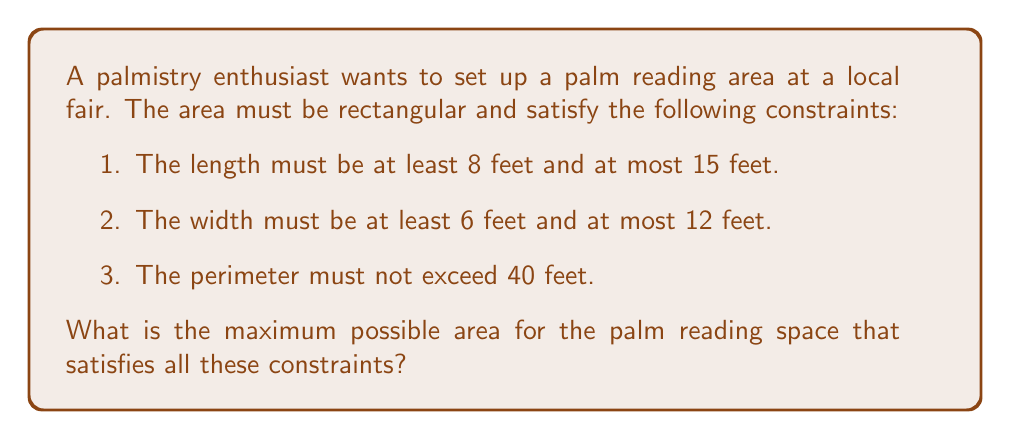What is the answer to this math problem? Let's approach this step-by-step:

1) Let $x$ be the length and $y$ be the width of the rectangular area.

2) From the given constraints, we can write the system of inequalities:
   $$8 \leq x \leq 15$$
   $$6 \leq y \leq 12$$
   $$2x + 2y \leq 40$$ (perimeter constraint)

3) The area of the rectangle is given by $A = xy$. We want to maximize this.

4) In a rectangular maximization problem with linear constraints, the maximum always occurs at a corner point of the feasible region.

5) The corner points are the intersections of the constraint lines. Let's find them:
   a) $(8, 6)$
   b) $(15, 6)$
   c) $(15, 5)$ (from $2x + 2y = 40$)
   d) $(8, 12)$

6) Let's calculate the area for each point:
   a) $A = 8 \times 6 = 48$ sq ft
   b) $A = 15 \times 6 = 90$ sq ft
   c) $A = 15 \times 5 = 75$ sq ft
   d) $A = 8 \times 12 = 96$ sq ft

7) The maximum area is 96 square feet, occurring at the point (8, 12).
Answer: 96 square feet 